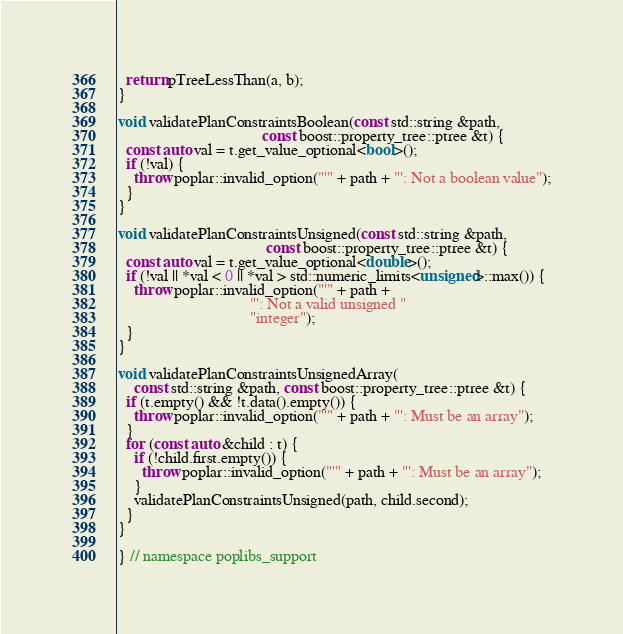<code> <loc_0><loc_0><loc_500><loc_500><_C++_>  return pTreeLessThan(a, b);
}

void validatePlanConstraintsBoolean(const std::string &path,
                                    const boost::property_tree::ptree &t) {
  const auto val = t.get_value_optional<bool>();
  if (!val) {
    throw poplar::invalid_option("'" + path + "': Not a boolean value");
  }
}

void validatePlanConstraintsUnsigned(const std::string &path,
                                     const boost::property_tree::ptree &t) {
  const auto val = t.get_value_optional<double>();
  if (!val || *val < 0 || *val > std::numeric_limits<unsigned>::max()) {
    throw poplar::invalid_option("'" + path +
                                 "': Not a valid unsigned "
                                 "integer");
  }
}

void validatePlanConstraintsUnsignedArray(
    const std::string &path, const boost::property_tree::ptree &t) {
  if (t.empty() && !t.data().empty()) {
    throw poplar::invalid_option("'" + path + "': Must be an array");
  }
  for (const auto &child : t) {
    if (!child.first.empty()) {
      throw poplar::invalid_option("'" + path + "': Must be an array");
    }
    validatePlanConstraintsUnsigned(path, child.second);
  }
}

} // namespace poplibs_support
</code> 